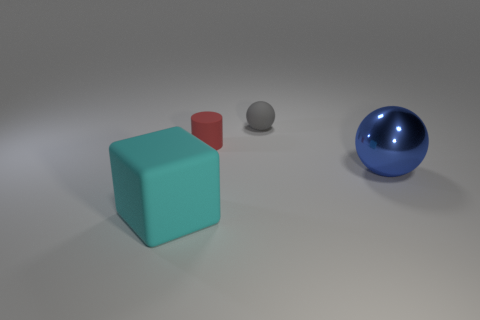Add 1 blue spheres. How many objects exist? 5 Subtract all cylinders. How many objects are left? 3 Subtract all green objects. Subtract all cyan cubes. How many objects are left? 3 Add 2 large blue objects. How many large blue objects are left? 3 Add 1 big blue things. How many big blue things exist? 2 Subtract 0 red balls. How many objects are left? 4 